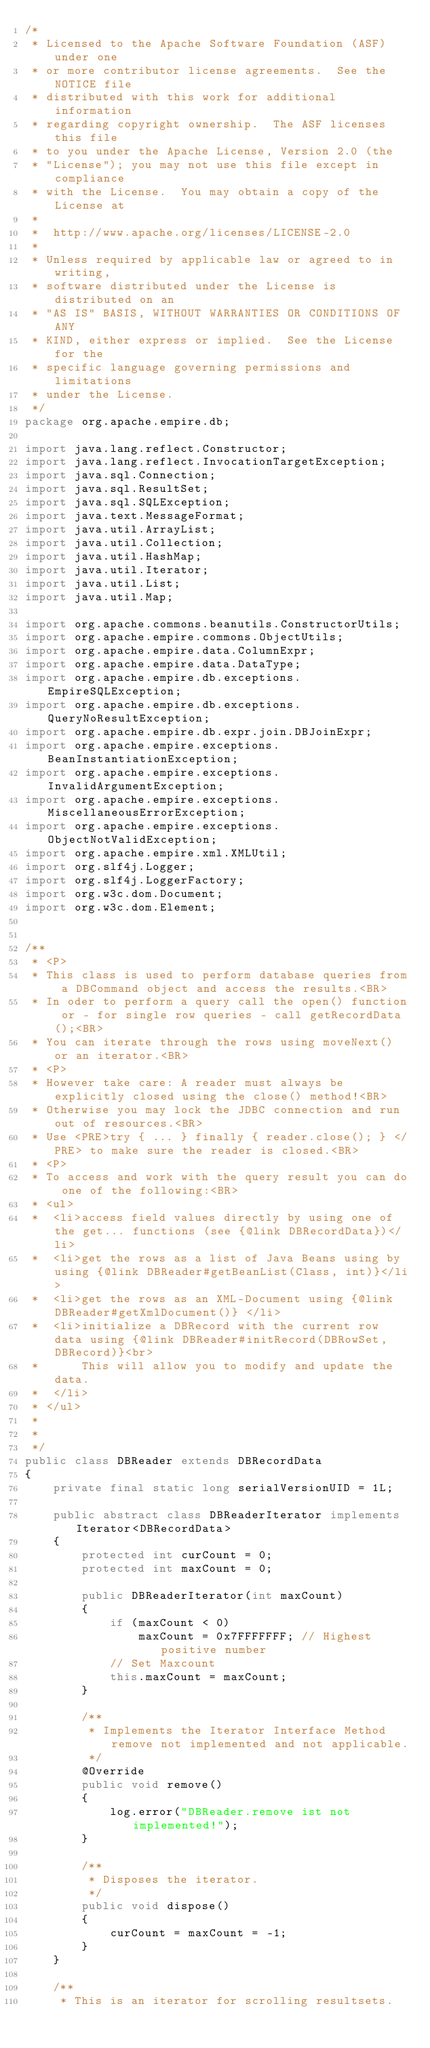Convert code to text. <code><loc_0><loc_0><loc_500><loc_500><_Java_>/*
 * Licensed to the Apache Software Foundation (ASF) under one
 * or more contributor license agreements.  See the NOTICE file
 * distributed with this work for additional information
 * regarding copyright ownership.  The ASF licenses this file
 * to you under the Apache License, Version 2.0 (the
 * "License"); you may not use this file except in compliance
 * with the License.  You may obtain a copy of the License at
 *
 *  http://www.apache.org/licenses/LICENSE-2.0
 *
 * Unless required by applicable law or agreed to in writing,
 * software distributed under the License is distributed on an
 * "AS IS" BASIS, WITHOUT WARRANTIES OR CONDITIONS OF ANY
 * KIND, either express or implied.  See the License for the
 * specific language governing permissions and limitations
 * under the License.
 */
package org.apache.empire.db;

import java.lang.reflect.Constructor;
import java.lang.reflect.InvocationTargetException;
import java.sql.Connection;
import java.sql.ResultSet;
import java.sql.SQLException;
import java.text.MessageFormat;
import java.util.ArrayList;
import java.util.Collection;
import java.util.HashMap;
import java.util.Iterator;
import java.util.List;
import java.util.Map;

import org.apache.commons.beanutils.ConstructorUtils;
import org.apache.empire.commons.ObjectUtils;
import org.apache.empire.data.ColumnExpr;
import org.apache.empire.data.DataType;
import org.apache.empire.db.exceptions.EmpireSQLException;
import org.apache.empire.db.exceptions.QueryNoResultException;
import org.apache.empire.db.expr.join.DBJoinExpr;
import org.apache.empire.exceptions.BeanInstantiationException;
import org.apache.empire.exceptions.InvalidArgumentException;
import org.apache.empire.exceptions.MiscellaneousErrorException;
import org.apache.empire.exceptions.ObjectNotValidException;
import org.apache.empire.xml.XMLUtil;
import org.slf4j.Logger;
import org.slf4j.LoggerFactory;
import org.w3c.dom.Document;
import org.w3c.dom.Element;


/**
 * <P>
 * This class is used to perform database queries from a DBCommand object and access the results.<BR>
 * In oder to perform a query call the open() function or - for single row queries - call getRecordData();<BR>
 * You can iterate through the rows using moveNext() or an iterator.<BR>
 * <P>
 * However take care: A reader must always be explicitly closed using the close() method!<BR>
 * Otherwise you may lock the JDBC connection and run out of resources.<BR>
 * Use <PRE>try { ... } finally { reader.close(); } </PRE> to make sure the reader is closed.<BR>
 * <P>
 * To access and work with the query result you can do one of the following:<BR>
 * <ul>
 *  <li>access field values directly by using one of the get... functions (see {@link DBRecordData})</li> 
 *  <li>get the rows as a list of Java Beans using by using {@link DBReader#getBeanList(Class, int)}</li> 
 *  <li>get the rows as an XML-Document using {@link DBReader#getXmlDocument()} </li> 
 *  <li>initialize a DBRecord with the current row data using {@link DBReader#initRecord(DBRowSet, DBRecord)}<br>
 *      This will allow you to modify and update the data. 
 *  </li> 
 * </ul>
 *
 *
 */
public class DBReader extends DBRecordData
{
    private final static long serialVersionUID = 1L;
  
    public abstract class DBReaderIterator implements Iterator<DBRecordData>
    {
        protected int curCount = 0;
        protected int maxCount = 0;

        public DBReaderIterator(int maxCount)
        {
            if (maxCount < 0)
                maxCount = 0x7FFFFFFF; // Highest positive number
            // Set Maxcount
            this.maxCount = maxCount;
        }

        /**
         * Implements the Iterator Interface Method remove not implemented and not applicable.
         */
        @Override
        public void remove()
        {
            log.error("DBReader.remove ist not implemented!");
        }

        /**
         * Disposes the iterator.
         */
        public void dispose()
        {
            curCount = maxCount = -1;
        }
    }

    /**
     * This is an iterator for scrolling resultsets.</code> 